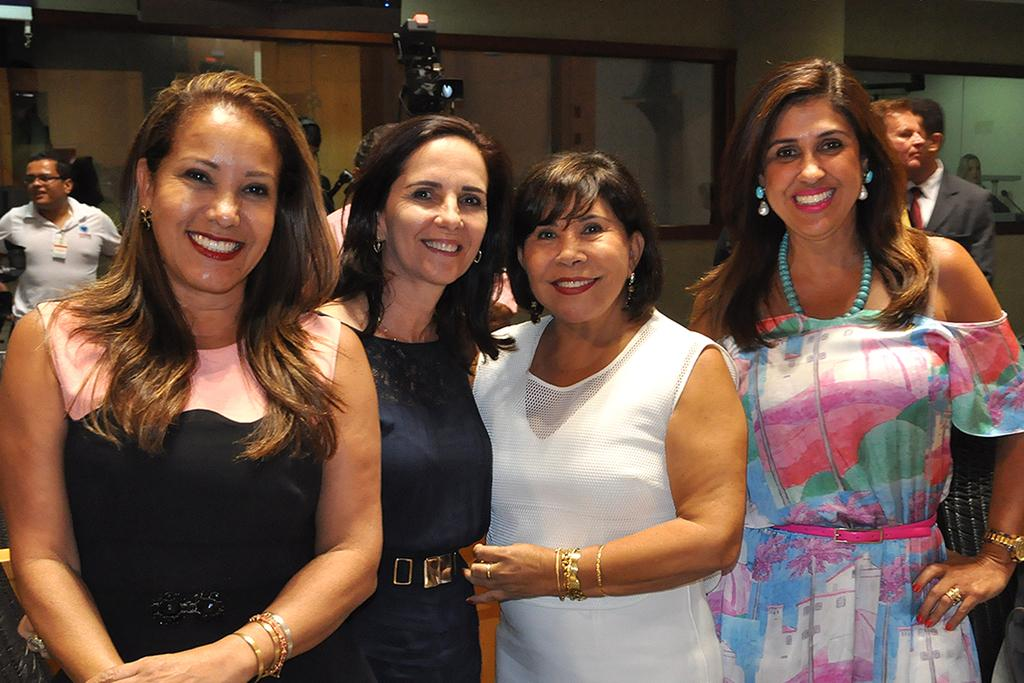Who is present in the image? There are women in the image. What are the women doing in the image? The women are smiling in the image. Where are the women standing in the image? The women are standing on the floor in the image. What else can be seen in the background of the image? There are men, cameras, and walls in the background of the image. What are the men doing in the image? The men are standing on the floor in the background of the image. What type of pump is visible in the image? There is no pump present in the image. What is the cause of the coughing sound heard in the image? There is no sound, including coughing, present in the image. 